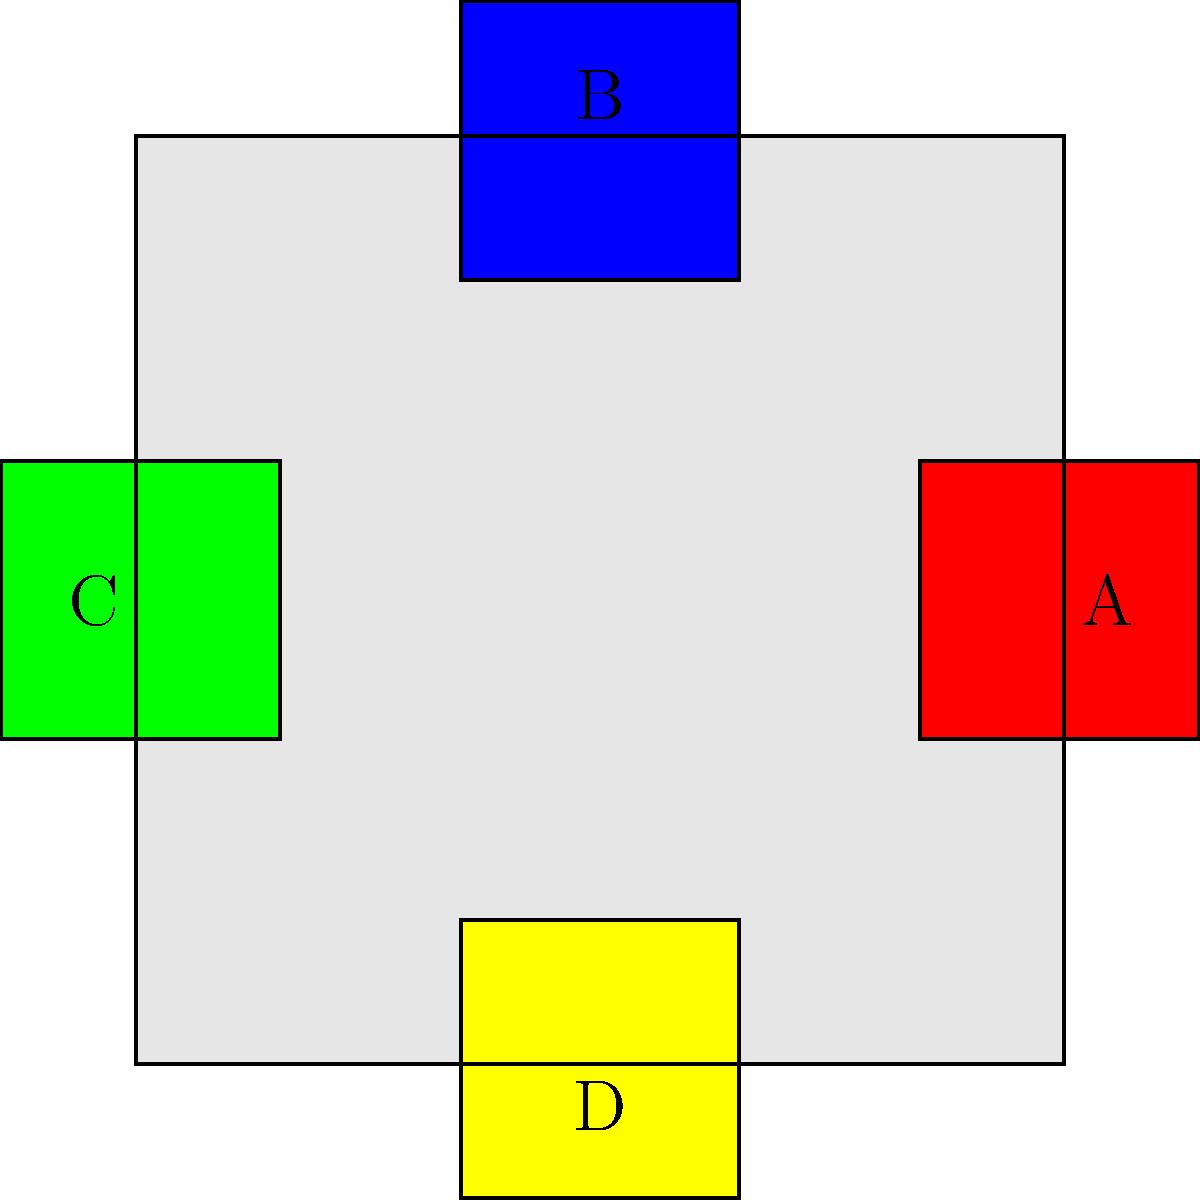In a Taekwondo competition, you need to mentally assemble a mat layout. The main mat is represented by the large gray square, and the colored squares (A, B, C, D) represent different sections. If you rotate the entire layout 90 degrees clockwise, which colored section will be in the position currently occupied by section A? To solve this problem, let's follow these steps:

1. Visualize the current layout:
   - A (red) is on the right
   - B (blue) is at the top
   - C (green) is on the left
   - D (yellow) is at the bottom

2. Understand what a 90-degree clockwise rotation means:
   - Each section will move 90 degrees in the clockwise direction
   - The right side will become the bottom
   - The top will become the right side
   - The left will become the top
   - The bottom will become the left

3. Track the movement of each section:
   - A (currently right) will move to the bottom
   - B (currently top) will move to the right
   - C (currently left) will move to the top
   - D (currently bottom) will move to the left

4. Identify which section ends up in A's original position:
   - After the rotation, B will be on the right side, where A was originally located

Therefore, after a 90-degree clockwise rotation, section B will occupy the position currently held by section A.
Answer: B 